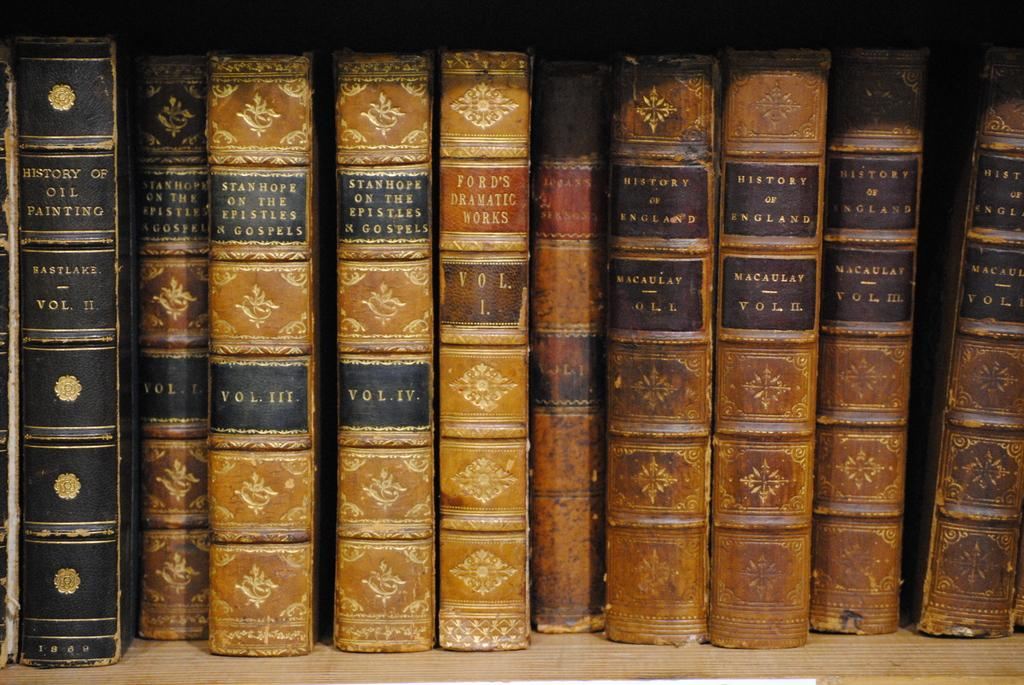What objects are present in the image? There are books in the image. Can you describe the colors of the books? The books are in brown, cream, and black colors. What is the color of the surface on which the books are placed? The books are on a cream-colored surface. How many clocks are visible on the books in the image? There are no clocks visible on the books in the image. 